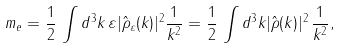Convert formula to latex. <formula><loc_0><loc_0><loc_500><loc_500>m _ { e } = \frac { 1 } { 2 } \, \int d ^ { 3 } k \, \varepsilon | \hat { \rho } _ { \varepsilon } ( k ) | ^ { 2 } \frac { 1 } { k ^ { 2 } } = \frac { 1 } { 2 } \, \int d ^ { 3 } k | \hat { \rho } ( k ) | ^ { 2 } \, \frac { 1 } { k ^ { 2 } } ,</formula> 